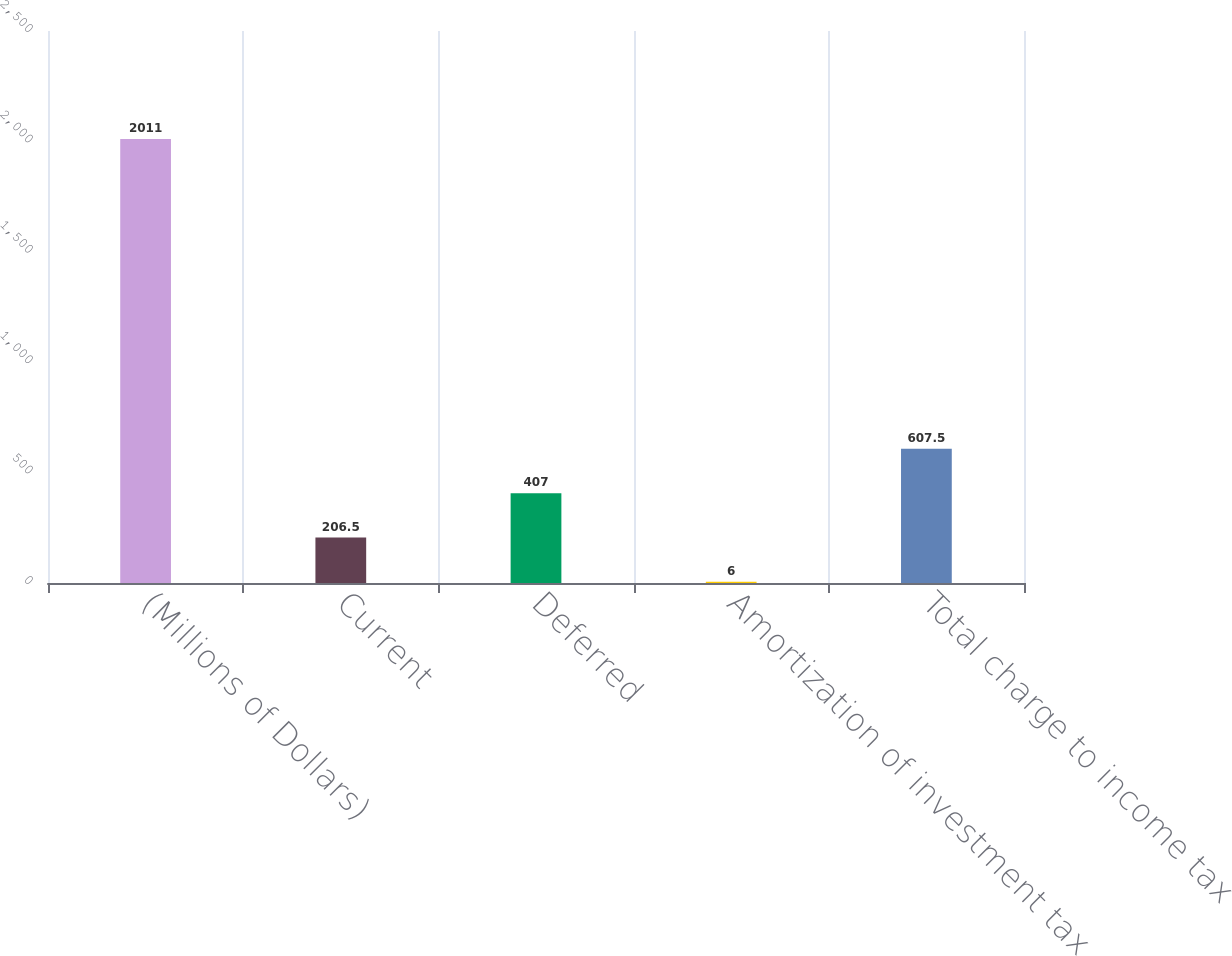<chart> <loc_0><loc_0><loc_500><loc_500><bar_chart><fcel>(Millions of Dollars)<fcel>Current<fcel>Deferred<fcel>Amortization of investment tax<fcel>Total charge to income tax<nl><fcel>2011<fcel>206.5<fcel>407<fcel>6<fcel>607.5<nl></chart> 